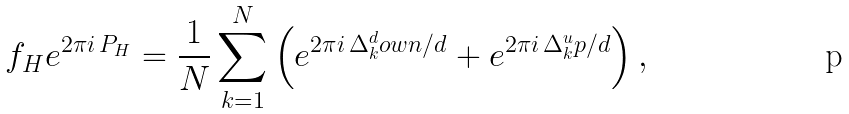Convert formula to latex. <formula><loc_0><loc_0><loc_500><loc_500>f _ { H } e ^ { 2 \pi i \, P _ { H } } = \frac { 1 } { N } \sum _ { k = 1 } ^ { N } \left ( e ^ { 2 \pi i \, \Delta _ { k } ^ { d } o w n / d } + e ^ { 2 \pi i \, \Delta _ { k } ^ { u } p / d } \right ) ,</formula> 